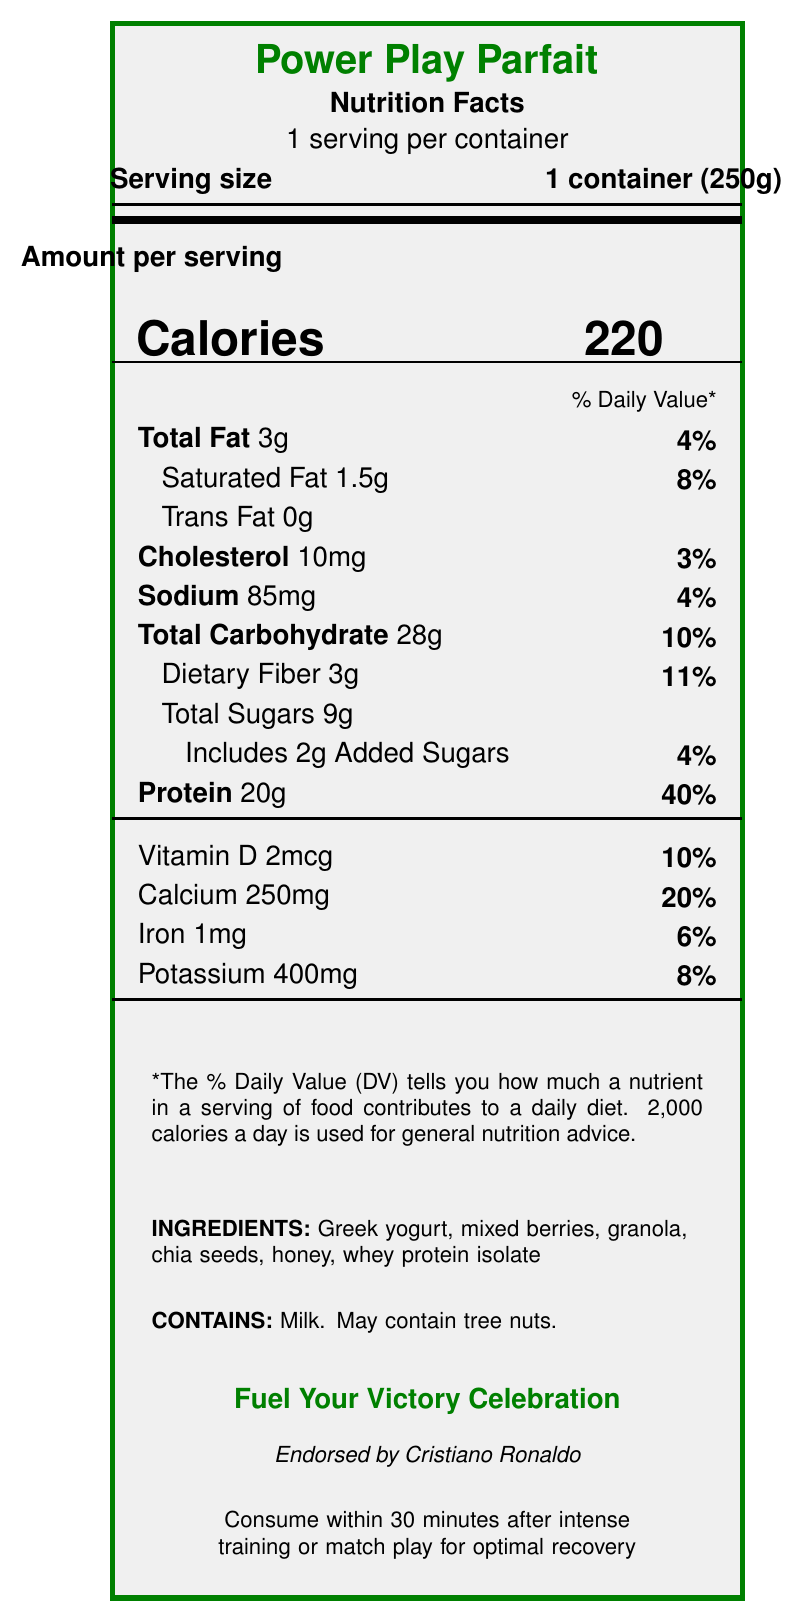what is the product name? The product name is prominently displayed at the top of the document.
Answer: Power Play Parfait how many calories are in one serving? The number of calories per serving is listed right under the "Amount per serving" section.
Answer: 220 what is the serving size for this yogurt parfait? The serving size is stated as "1 container (250g)" near the top of the document.
Answer: 1 container (250g) how much protein is in one serving? The protein content per serving is listed at the bottom of the main nutrition facts, showing 20g.
Answer: 20g what is the percentage daily value for calcium? The percentage daily value for calcium is listed under the vitamin and minerals section, showing it as 20%.
Answer: 20% how many grams of total sugars are in the parfait? The total sugars per serving are listed as 9g.
Answer: 9g which of the following nutrients has the highest percentage daily value? A. Total Fat B. Sodium C. Protein D. Dietary Fiber By comparing the percentage daily values, protein has the highest at 40%.
Answer: C. Protein how much dietary fiber does this product contain? A. 1g B. 2g C. 3g D. 4g The dietary fiber content is listed as 3g per serving.
Answer: C. 3g does this product contain any trans fat? The document states that the trans fat content is 0g.
Answer: No is it recommended to consume this product before or after a workout? The document recommends consuming it within 30 minutes after intense training or match play for optimal recovery.
Answer: After what ingredients are in this parfait? The ingredients are listed toward the bottom of the document.
Answer: Greek yogurt, mixed berries, granola, chia seeds, honey, whey protein isolate who endorses this yogurt parfait? The endorsement by Cristiano Ronaldo is mentioned near the bottom of the document.
Answer: Cristiano Ronaldo what is the main idea of this document? This document includes detailed nutrition information, ingredients, allergens, athlete endorsement, brand slogan, recovery benefits, and a consumption recommendation.
Answer: The document provides the nutrition facts and benefits of the Power Play Parfait, a protein-packed, low-sugar yogurt parfait endorsed by Cristiano Ronaldo, designed as a balanced post-workout snack to support muscle recovery, energy replenishment, and hydration. what is the brand slogan for Power Play Parfait? The brand slogan is "Fuel Your Victory Celebration" and is prominently displayed near the bottom of the document.
Answer: Fuel Your Victory Celebration how many servings are there per container? It is stated that there is 1 serving per container.
Answer: 1 what are the key nutrients for athletes mentioned in this document? These nutrients are highlighted as key for athletes in the document.
Answer: High-quality protein for muscle repair, complex carbohydrates for energy replenishment, antioxidants from berries to reduce inflammation cannot be answered based on the document This information is not provided in the document.
Answer: How much does the product cost? 